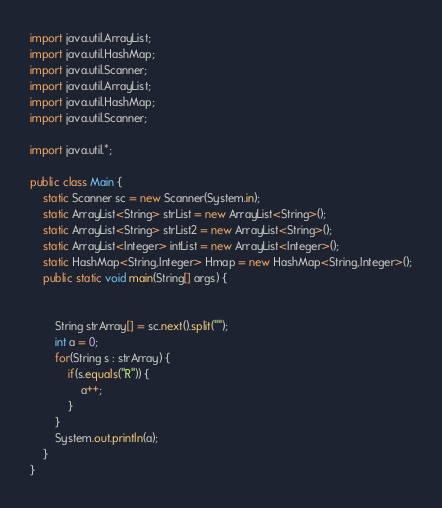Convert code to text. <code><loc_0><loc_0><loc_500><loc_500><_Java_>import java.util.ArrayList;
import java.util.HashMap;
import java.util.Scanner;
import java.util.ArrayList;
import java.util.HashMap;
import java.util.Scanner;

import java.util.*;

public class Main {
	static Scanner sc = new Scanner(System.in);
	static ArrayList<String> strList = new ArrayList<String>();
	static ArrayList<String> strList2 = new ArrayList<String>();
	static ArrayList<Integer> intList = new ArrayList<Integer>();
	static HashMap<String,Integer> Hmap = new HashMap<String,Integer>();
	public static void main(String[] args) {


		String strArray[] = sc.next().split("");
		int a = 0;
		for(String s : strArray) {
			if(s.equals("R")) {
				a++;
			}
		}
		System.out.println(a);
	}
}
</code> 